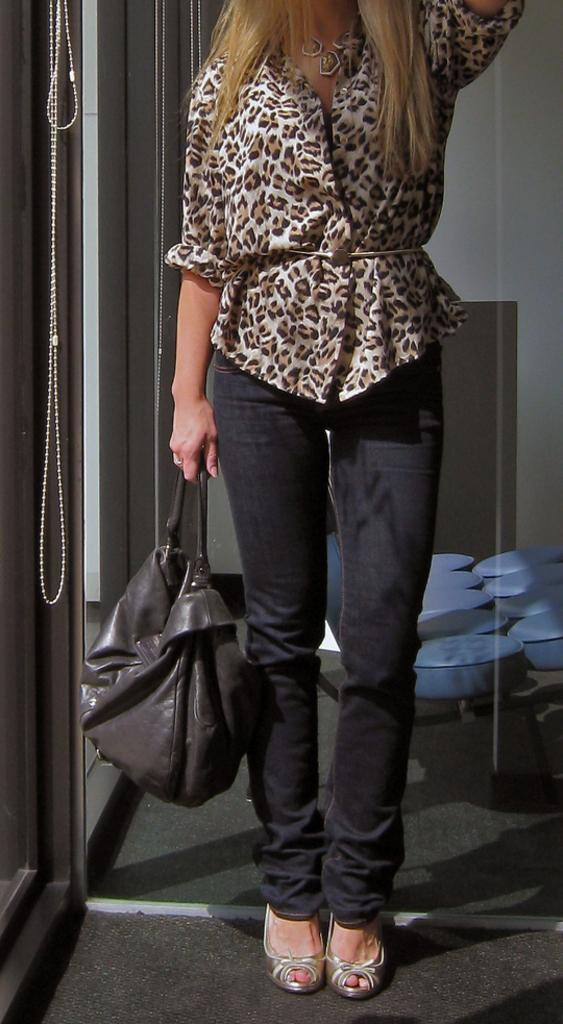Who is the main subject in the image? There is a woman in the image. What is the woman doing in the image? The woman is standing. What is the woman holding in the image? The woman is carrying a bag in one hand. What can be seen in the background of the image? There is a window and seats visible in the background of the image. What type of hill can be seen in the background of the image? There is no hill visible in the background of the image. What is the governor doing in the image? There is no governor present in the image. 